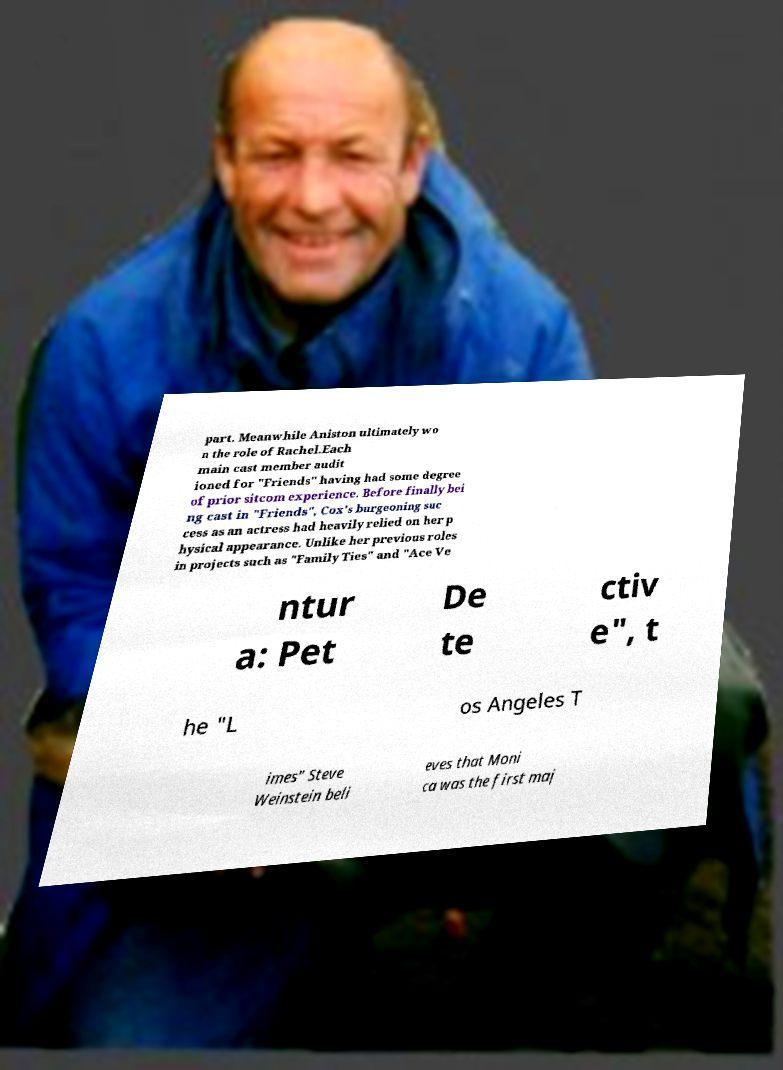Could you assist in decoding the text presented in this image and type it out clearly? part. Meanwhile Aniston ultimately wo n the role of Rachel.Each main cast member audit ioned for "Friends" having had some degree of prior sitcom experience. Before finally bei ng cast in "Friends", Cox's burgeoning suc cess as an actress had heavily relied on her p hysical appearance. Unlike her previous roles in projects such as "Family Ties" and "Ace Ve ntur a: Pet De te ctiv e", t he "L os Angeles T imes" Steve Weinstein beli eves that Moni ca was the first maj 